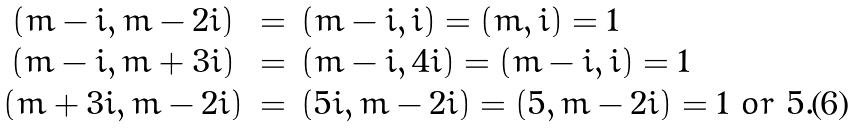<formula> <loc_0><loc_0><loc_500><loc_500>\begin{array} { c l l } ( m - i , m - 2 i ) & = & ( m - i , i ) = ( m , i ) = 1 \\ ( m - i , m + 3 i ) & = & ( m - i , 4 i ) = ( m - i , i ) = 1 \\ ( m + 3 i , m - 2 i ) & = & ( 5 i , m - 2 i ) = ( 5 , m - 2 i ) = 1 \ o r \ 5 . \\ \end{array}</formula> 